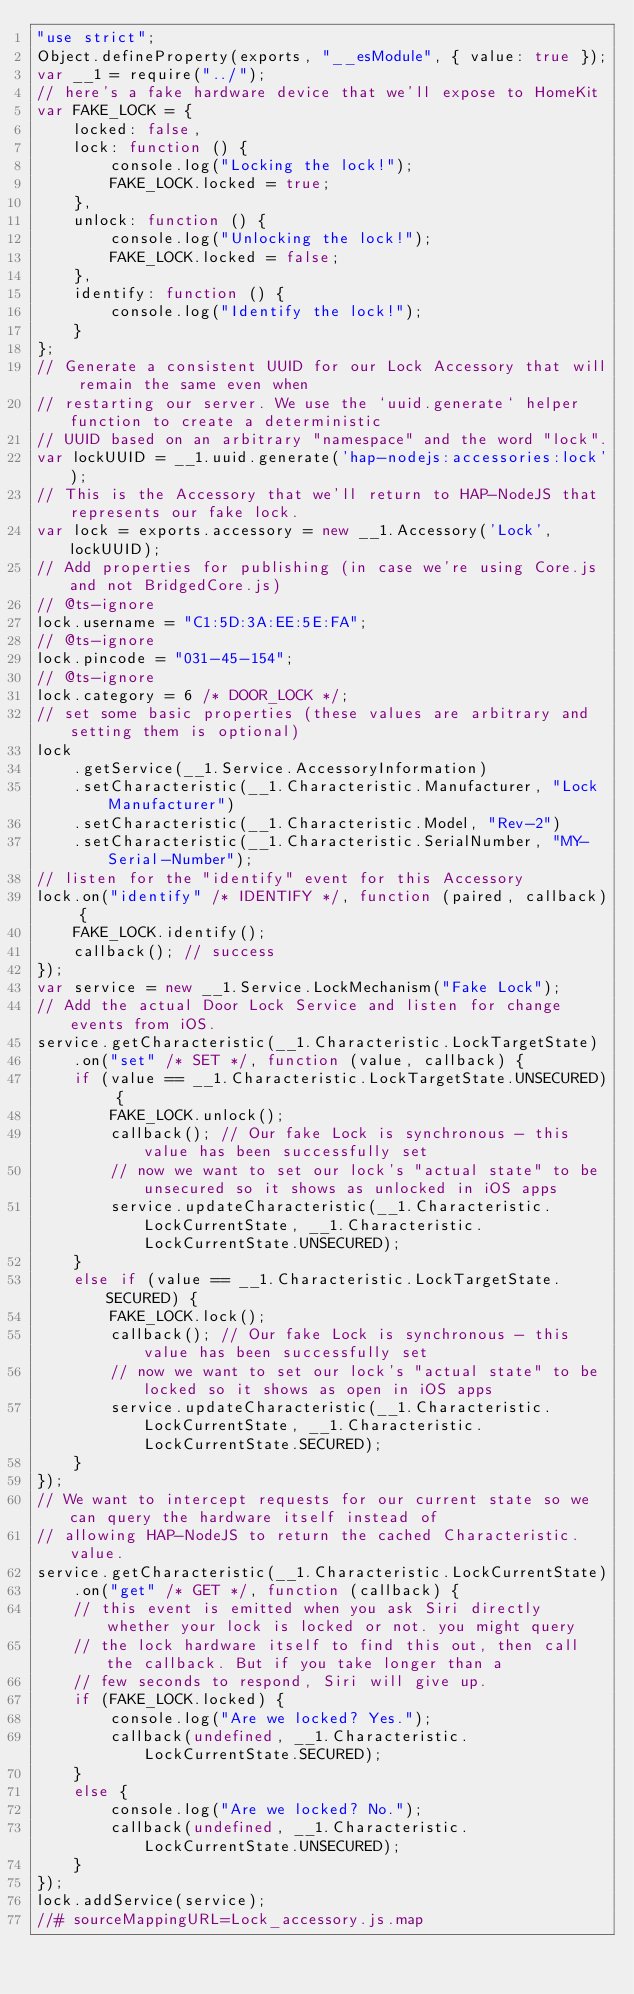<code> <loc_0><loc_0><loc_500><loc_500><_JavaScript_>"use strict";
Object.defineProperty(exports, "__esModule", { value: true });
var __1 = require("../");
// here's a fake hardware device that we'll expose to HomeKit
var FAKE_LOCK = {
    locked: false,
    lock: function () {
        console.log("Locking the lock!");
        FAKE_LOCK.locked = true;
    },
    unlock: function () {
        console.log("Unlocking the lock!");
        FAKE_LOCK.locked = false;
    },
    identify: function () {
        console.log("Identify the lock!");
    }
};
// Generate a consistent UUID for our Lock Accessory that will remain the same even when
// restarting our server. We use the `uuid.generate` helper function to create a deterministic
// UUID based on an arbitrary "namespace" and the word "lock".
var lockUUID = __1.uuid.generate('hap-nodejs:accessories:lock');
// This is the Accessory that we'll return to HAP-NodeJS that represents our fake lock.
var lock = exports.accessory = new __1.Accessory('Lock', lockUUID);
// Add properties for publishing (in case we're using Core.js and not BridgedCore.js)
// @ts-ignore
lock.username = "C1:5D:3A:EE:5E:FA";
// @ts-ignore
lock.pincode = "031-45-154";
// @ts-ignore
lock.category = 6 /* DOOR_LOCK */;
// set some basic properties (these values are arbitrary and setting them is optional)
lock
    .getService(__1.Service.AccessoryInformation)
    .setCharacteristic(__1.Characteristic.Manufacturer, "Lock Manufacturer")
    .setCharacteristic(__1.Characteristic.Model, "Rev-2")
    .setCharacteristic(__1.Characteristic.SerialNumber, "MY-Serial-Number");
// listen for the "identify" event for this Accessory
lock.on("identify" /* IDENTIFY */, function (paired, callback) {
    FAKE_LOCK.identify();
    callback(); // success
});
var service = new __1.Service.LockMechanism("Fake Lock");
// Add the actual Door Lock Service and listen for change events from iOS.
service.getCharacteristic(__1.Characteristic.LockTargetState)
    .on("set" /* SET */, function (value, callback) {
    if (value == __1.Characteristic.LockTargetState.UNSECURED) {
        FAKE_LOCK.unlock();
        callback(); // Our fake Lock is synchronous - this value has been successfully set
        // now we want to set our lock's "actual state" to be unsecured so it shows as unlocked in iOS apps
        service.updateCharacteristic(__1.Characteristic.LockCurrentState, __1.Characteristic.LockCurrentState.UNSECURED);
    }
    else if (value == __1.Characteristic.LockTargetState.SECURED) {
        FAKE_LOCK.lock();
        callback(); // Our fake Lock is synchronous - this value has been successfully set
        // now we want to set our lock's "actual state" to be locked so it shows as open in iOS apps
        service.updateCharacteristic(__1.Characteristic.LockCurrentState, __1.Characteristic.LockCurrentState.SECURED);
    }
});
// We want to intercept requests for our current state so we can query the hardware itself instead of
// allowing HAP-NodeJS to return the cached Characteristic.value.
service.getCharacteristic(__1.Characteristic.LockCurrentState)
    .on("get" /* GET */, function (callback) {
    // this event is emitted when you ask Siri directly whether your lock is locked or not. you might query
    // the lock hardware itself to find this out, then call the callback. But if you take longer than a
    // few seconds to respond, Siri will give up.
    if (FAKE_LOCK.locked) {
        console.log("Are we locked? Yes.");
        callback(undefined, __1.Characteristic.LockCurrentState.SECURED);
    }
    else {
        console.log("Are we locked? No.");
        callback(undefined, __1.Characteristic.LockCurrentState.UNSECURED);
    }
});
lock.addService(service);
//# sourceMappingURL=Lock_accessory.js.map</code> 